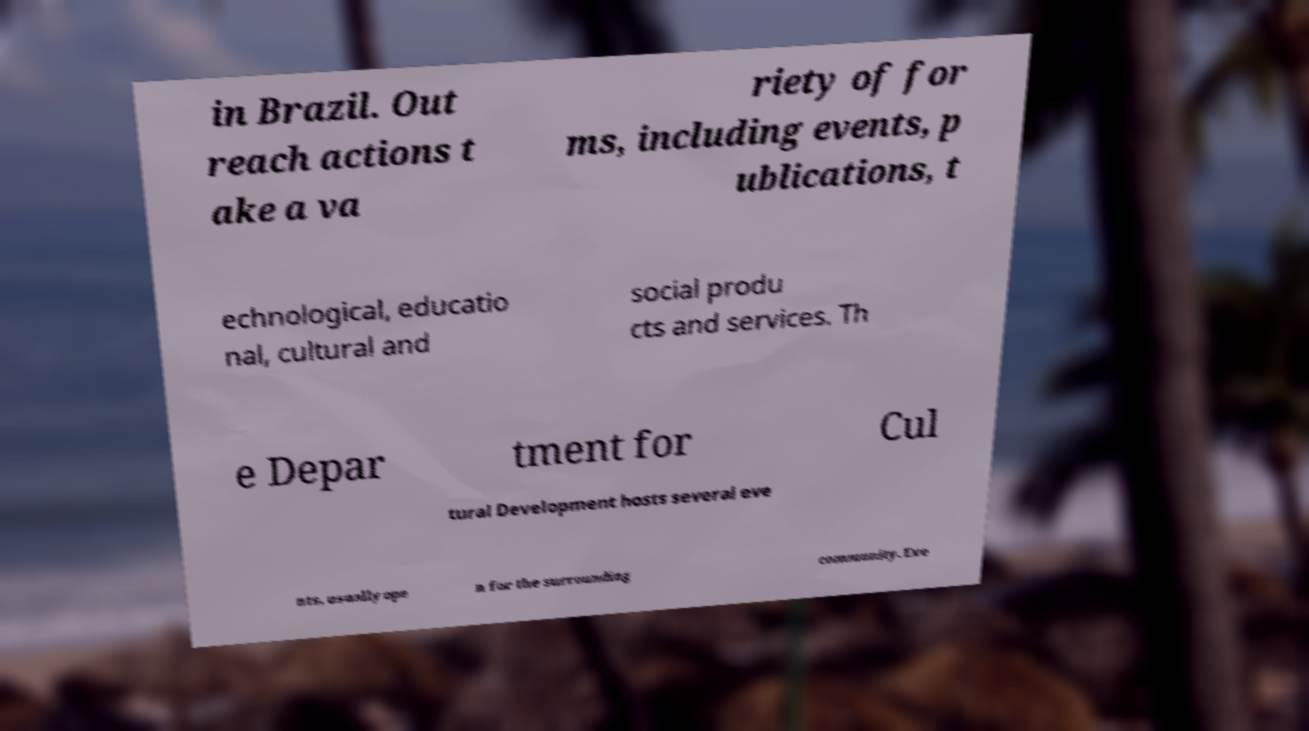I need the written content from this picture converted into text. Can you do that? in Brazil. Out reach actions t ake a va riety of for ms, including events, p ublications, t echnological, educatio nal, cultural and social produ cts and services. Th e Depar tment for Cul tural Development hosts several eve nts, usually ope n for the surrounding community. Eve 